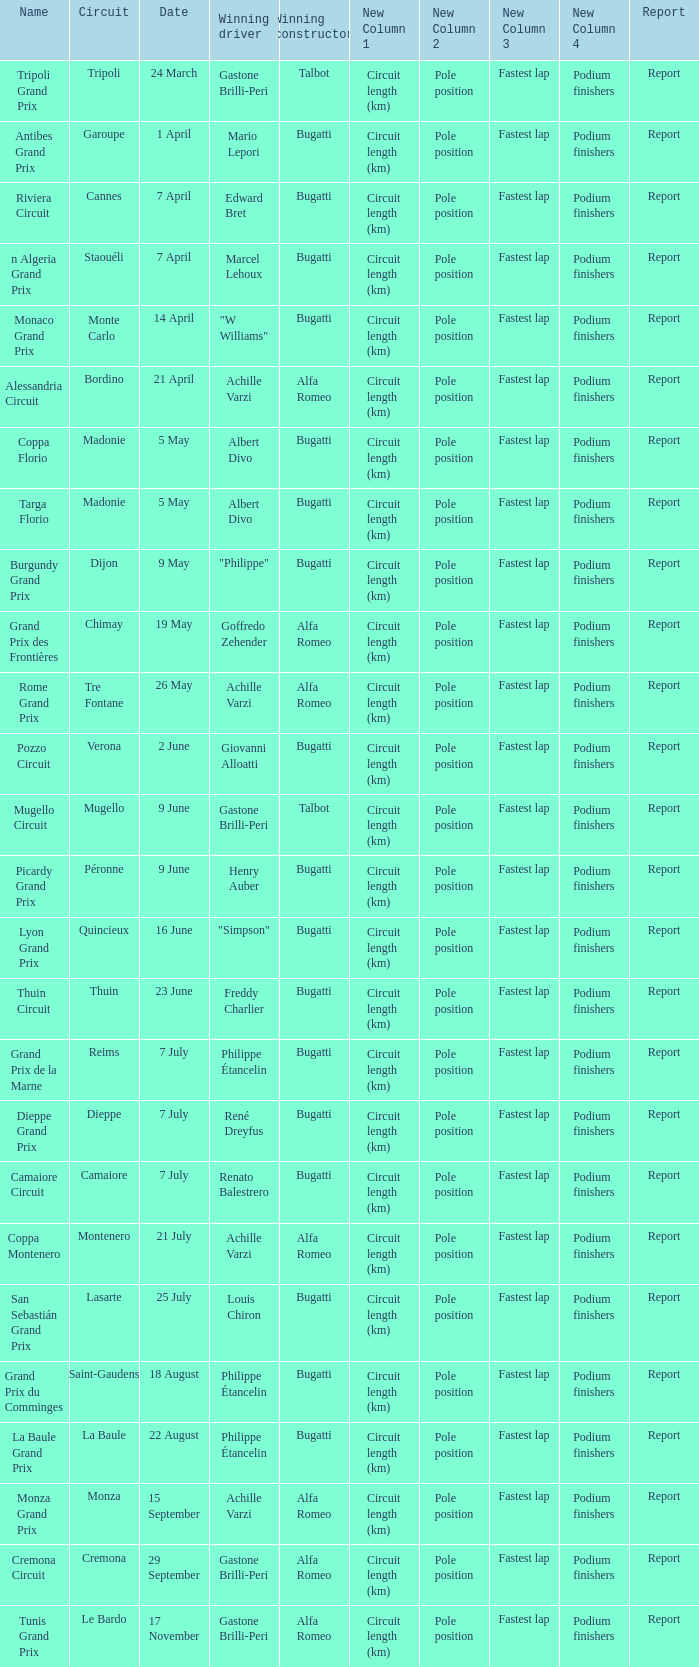What Date has a Name of thuin circuit? 23 June. 